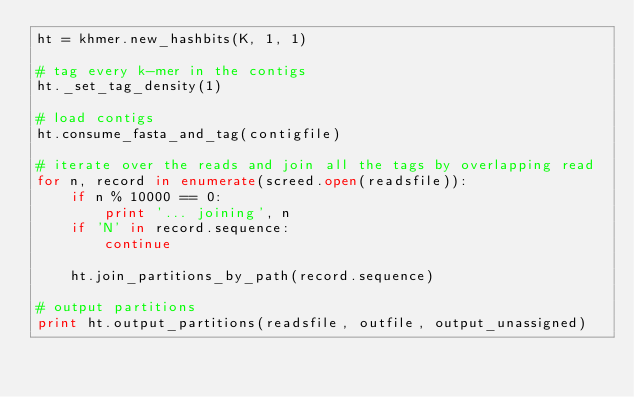Convert code to text. <code><loc_0><loc_0><loc_500><loc_500><_Python_>ht = khmer.new_hashbits(K, 1, 1)

# tag every k-mer in the contigs
ht._set_tag_density(1)

# load contigs
ht.consume_fasta_and_tag(contigfile)

# iterate over the reads and join all the tags by overlapping read
for n, record in enumerate(screed.open(readsfile)):
    if n % 10000 == 0:
        print '... joining', n
    if 'N' in record.sequence:
        continue

    ht.join_partitions_by_path(record.sequence)

# output partitions
print ht.output_partitions(readsfile, outfile, output_unassigned)
</code> 